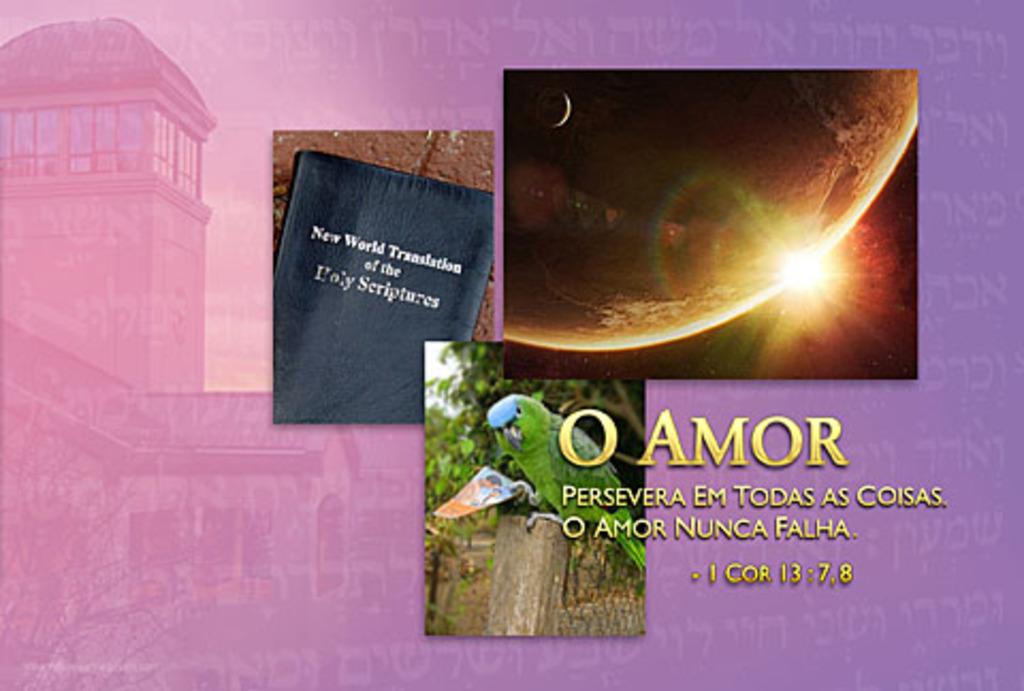What is the title of the black leather book?
Make the answer very short. New world translation of the holy scriptures. What is the name in yellow?
Provide a short and direct response. O amor. 